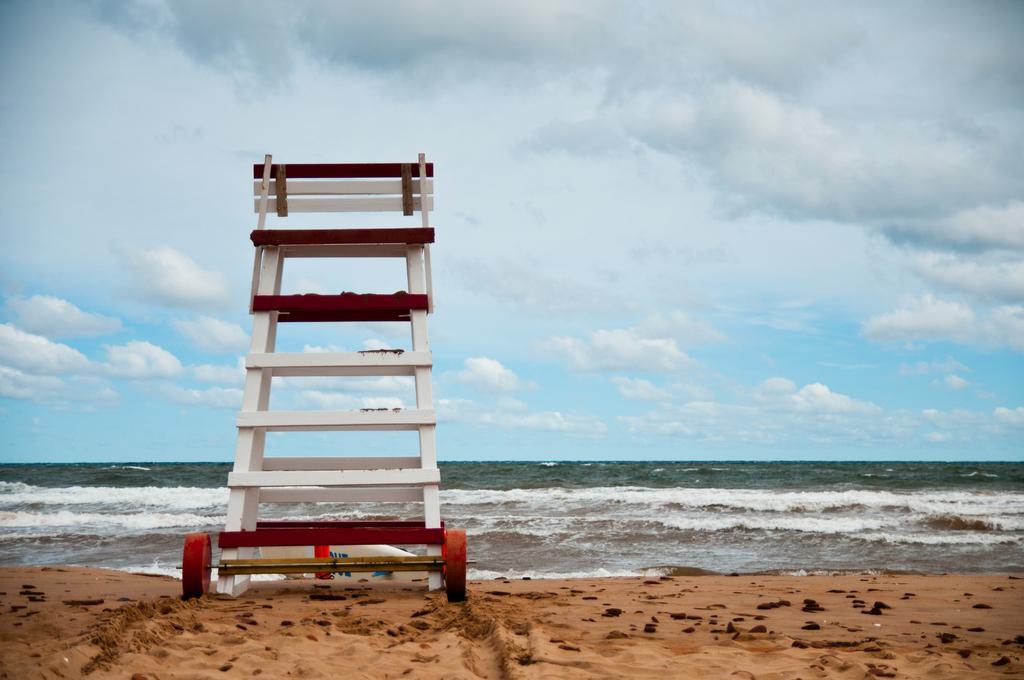Please provide a concise description of this image. In this picture we can observe white color ladder with wheels in the beach. We can observe sand. In the background there is an ocean and a sky with some clouds. 